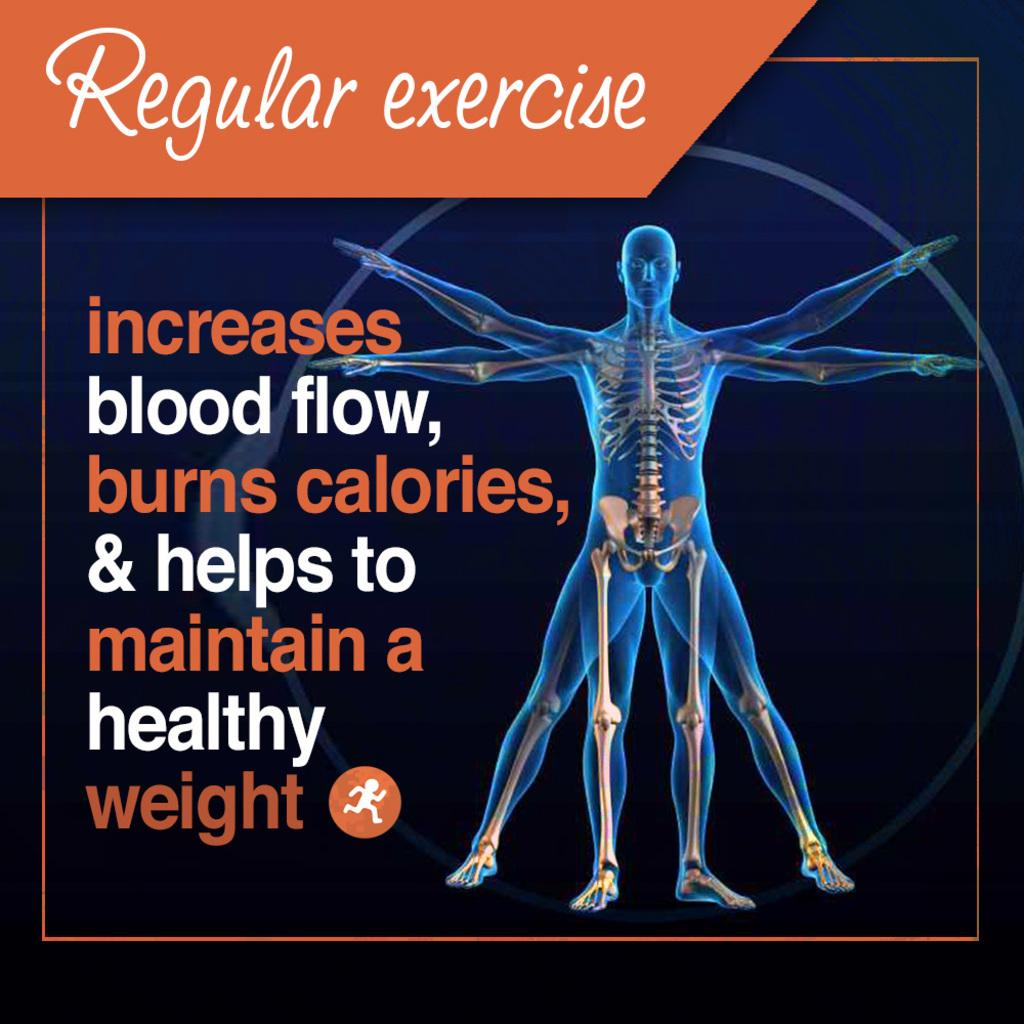<image>
Write a terse but informative summary of the picture. a page that says 'regular exercise' at the top 